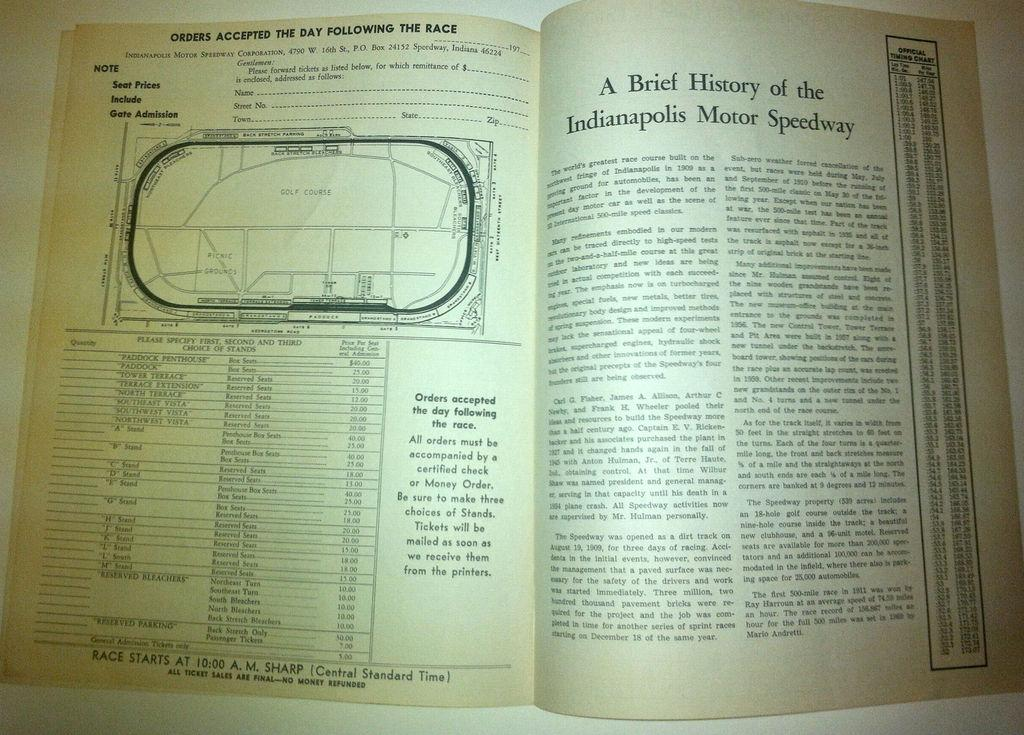<image>
Offer a succinct explanation of the picture presented. An open book that referring to A Brief History of the Indianapolis Motor Speedway. 